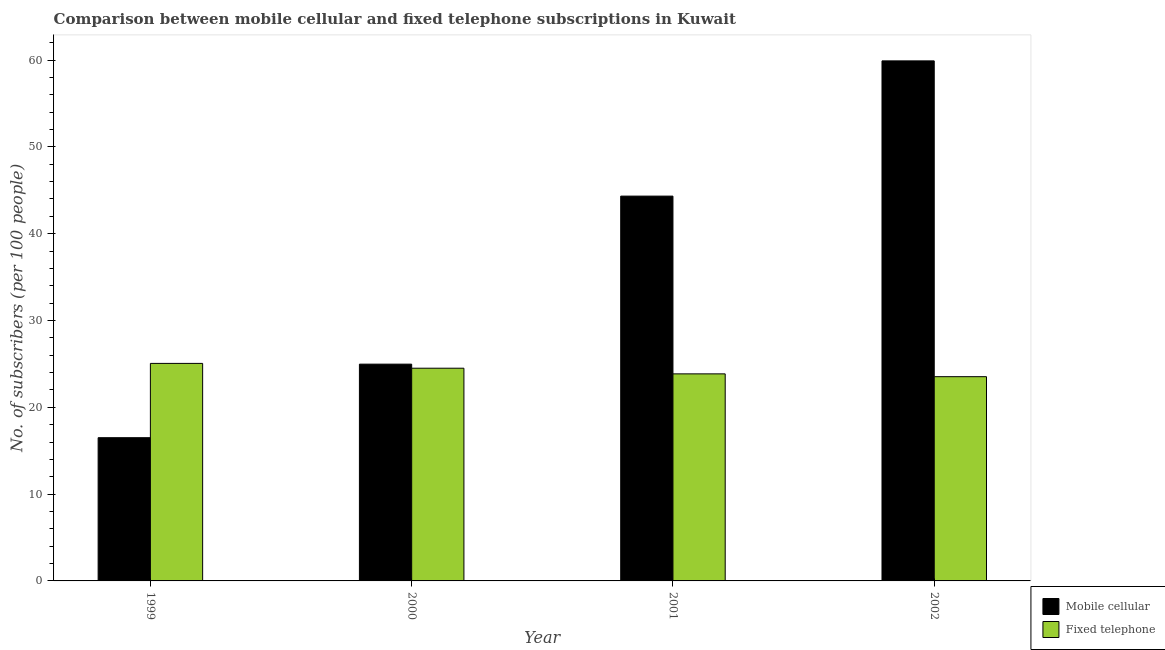How many different coloured bars are there?
Make the answer very short. 2. How many groups of bars are there?
Keep it short and to the point. 4. How many bars are there on the 3rd tick from the left?
Make the answer very short. 2. How many bars are there on the 4th tick from the right?
Ensure brevity in your answer.  2. In how many cases, is the number of bars for a given year not equal to the number of legend labels?
Your response must be concise. 0. What is the number of mobile cellular subscribers in 2000?
Ensure brevity in your answer.  24.97. Across all years, what is the maximum number of fixed telephone subscribers?
Your answer should be very brief. 25.06. Across all years, what is the minimum number of fixed telephone subscribers?
Give a very brief answer. 23.53. In which year was the number of mobile cellular subscribers minimum?
Give a very brief answer. 1999. What is the total number of fixed telephone subscribers in the graph?
Provide a succinct answer. 96.94. What is the difference between the number of fixed telephone subscribers in 2001 and that in 2002?
Give a very brief answer. 0.32. What is the difference between the number of mobile cellular subscribers in 2000 and the number of fixed telephone subscribers in 2002?
Provide a succinct answer. -34.93. What is the average number of fixed telephone subscribers per year?
Offer a terse response. 24.23. In the year 1999, what is the difference between the number of fixed telephone subscribers and number of mobile cellular subscribers?
Your answer should be compact. 0. What is the ratio of the number of mobile cellular subscribers in 1999 to that in 2001?
Your response must be concise. 0.37. Is the difference between the number of mobile cellular subscribers in 1999 and 2002 greater than the difference between the number of fixed telephone subscribers in 1999 and 2002?
Provide a short and direct response. No. What is the difference between the highest and the second highest number of fixed telephone subscribers?
Ensure brevity in your answer.  0.56. What is the difference between the highest and the lowest number of fixed telephone subscribers?
Ensure brevity in your answer.  1.53. Is the sum of the number of mobile cellular subscribers in 2000 and 2001 greater than the maximum number of fixed telephone subscribers across all years?
Ensure brevity in your answer.  Yes. What does the 1st bar from the left in 1999 represents?
Give a very brief answer. Mobile cellular. What does the 1st bar from the right in 2000 represents?
Make the answer very short. Fixed telephone. Are all the bars in the graph horizontal?
Keep it short and to the point. No. How many years are there in the graph?
Your response must be concise. 4. Are the values on the major ticks of Y-axis written in scientific E-notation?
Provide a short and direct response. No. Does the graph contain grids?
Offer a terse response. No. Where does the legend appear in the graph?
Provide a succinct answer. Bottom right. How many legend labels are there?
Ensure brevity in your answer.  2. What is the title of the graph?
Your answer should be compact. Comparison between mobile cellular and fixed telephone subscriptions in Kuwait. What is the label or title of the Y-axis?
Your response must be concise. No. of subscribers (per 100 people). What is the No. of subscribers (per 100 people) in Mobile cellular in 1999?
Give a very brief answer. 16.5. What is the No. of subscribers (per 100 people) in Fixed telephone in 1999?
Offer a terse response. 25.06. What is the No. of subscribers (per 100 people) in Mobile cellular in 2000?
Provide a short and direct response. 24.97. What is the No. of subscribers (per 100 people) of Fixed telephone in 2000?
Your answer should be compact. 24.5. What is the No. of subscribers (per 100 people) of Mobile cellular in 2001?
Keep it short and to the point. 44.33. What is the No. of subscribers (per 100 people) of Fixed telephone in 2001?
Offer a very short reply. 23.85. What is the No. of subscribers (per 100 people) of Mobile cellular in 2002?
Ensure brevity in your answer.  59.91. What is the No. of subscribers (per 100 people) in Fixed telephone in 2002?
Your answer should be compact. 23.53. Across all years, what is the maximum No. of subscribers (per 100 people) in Mobile cellular?
Your answer should be compact. 59.91. Across all years, what is the maximum No. of subscribers (per 100 people) of Fixed telephone?
Provide a succinct answer. 25.06. Across all years, what is the minimum No. of subscribers (per 100 people) of Mobile cellular?
Your response must be concise. 16.5. Across all years, what is the minimum No. of subscribers (per 100 people) of Fixed telephone?
Provide a short and direct response. 23.53. What is the total No. of subscribers (per 100 people) of Mobile cellular in the graph?
Your response must be concise. 145.7. What is the total No. of subscribers (per 100 people) of Fixed telephone in the graph?
Provide a short and direct response. 96.94. What is the difference between the No. of subscribers (per 100 people) in Mobile cellular in 1999 and that in 2000?
Keep it short and to the point. -8.47. What is the difference between the No. of subscribers (per 100 people) of Fixed telephone in 1999 and that in 2000?
Provide a short and direct response. 0.56. What is the difference between the No. of subscribers (per 100 people) of Mobile cellular in 1999 and that in 2001?
Offer a terse response. -27.83. What is the difference between the No. of subscribers (per 100 people) in Fixed telephone in 1999 and that in 2001?
Keep it short and to the point. 1.21. What is the difference between the No. of subscribers (per 100 people) in Mobile cellular in 1999 and that in 2002?
Give a very brief answer. -43.41. What is the difference between the No. of subscribers (per 100 people) in Fixed telephone in 1999 and that in 2002?
Offer a very short reply. 1.53. What is the difference between the No. of subscribers (per 100 people) of Mobile cellular in 2000 and that in 2001?
Offer a terse response. -19.36. What is the difference between the No. of subscribers (per 100 people) in Fixed telephone in 2000 and that in 2001?
Your answer should be very brief. 0.65. What is the difference between the No. of subscribers (per 100 people) in Mobile cellular in 2000 and that in 2002?
Give a very brief answer. -34.93. What is the difference between the No. of subscribers (per 100 people) of Fixed telephone in 2000 and that in 2002?
Your answer should be compact. 0.97. What is the difference between the No. of subscribers (per 100 people) in Mobile cellular in 2001 and that in 2002?
Ensure brevity in your answer.  -15.58. What is the difference between the No. of subscribers (per 100 people) in Fixed telephone in 2001 and that in 2002?
Your response must be concise. 0.32. What is the difference between the No. of subscribers (per 100 people) of Mobile cellular in 1999 and the No. of subscribers (per 100 people) of Fixed telephone in 2000?
Make the answer very short. -8. What is the difference between the No. of subscribers (per 100 people) in Mobile cellular in 1999 and the No. of subscribers (per 100 people) in Fixed telephone in 2001?
Offer a terse response. -7.35. What is the difference between the No. of subscribers (per 100 people) in Mobile cellular in 1999 and the No. of subscribers (per 100 people) in Fixed telephone in 2002?
Your response must be concise. -7.03. What is the difference between the No. of subscribers (per 100 people) in Mobile cellular in 2000 and the No. of subscribers (per 100 people) in Fixed telephone in 2001?
Your response must be concise. 1.12. What is the difference between the No. of subscribers (per 100 people) in Mobile cellular in 2000 and the No. of subscribers (per 100 people) in Fixed telephone in 2002?
Offer a very short reply. 1.44. What is the difference between the No. of subscribers (per 100 people) of Mobile cellular in 2001 and the No. of subscribers (per 100 people) of Fixed telephone in 2002?
Your answer should be very brief. 20.8. What is the average No. of subscribers (per 100 people) in Mobile cellular per year?
Make the answer very short. 36.42. What is the average No. of subscribers (per 100 people) of Fixed telephone per year?
Offer a terse response. 24.23. In the year 1999, what is the difference between the No. of subscribers (per 100 people) of Mobile cellular and No. of subscribers (per 100 people) of Fixed telephone?
Ensure brevity in your answer.  -8.56. In the year 2000, what is the difference between the No. of subscribers (per 100 people) of Mobile cellular and No. of subscribers (per 100 people) of Fixed telephone?
Your response must be concise. 0.47. In the year 2001, what is the difference between the No. of subscribers (per 100 people) in Mobile cellular and No. of subscribers (per 100 people) in Fixed telephone?
Make the answer very short. 20.47. In the year 2002, what is the difference between the No. of subscribers (per 100 people) in Mobile cellular and No. of subscribers (per 100 people) in Fixed telephone?
Your answer should be very brief. 36.38. What is the ratio of the No. of subscribers (per 100 people) in Mobile cellular in 1999 to that in 2000?
Provide a short and direct response. 0.66. What is the ratio of the No. of subscribers (per 100 people) of Fixed telephone in 1999 to that in 2000?
Offer a very short reply. 1.02. What is the ratio of the No. of subscribers (per 100 people) of Mobile cellular in 1999 to that in 2001?
Your response must be concise. 0.37. What is the ratio of the No. of subscribers (per 100 people) in Fixed telephone in 1999 to that in 2001?
Provide a short and direct response. 1.05. What is the ratio of the No. of subscribers (per 100 people) of Mobile cellular in 1999 to that in 2002?
Your answer should be compact. 0.28. What is the ratio of the No. of subscribers (per 100 people) in Fixed telephone in 1999 to that in 2002?
Provide a short and direct response. 1.06. What is the ratio of the No. of subscribers (per 100 people) in Mobile cellular in 2000 to that in 2001?
Provide a succinct answer. 0.56. What is the ratio of the No. of subscribers (per 100 people) of Fixed telephone in 2000 to that in 2001?
Offer a terse response. 1.03. What is the ratio of the No. of subscribers (per 100 people) in Mobile cellular in 2000 to that in 2002?
Your response must be concise. 0.42. What is the ratio of the No. of subscribers (per 100 people) in Fixed telephone in 2000 to that in 2002?
Your answer should be very brief. 1.04. What is the ratio of the No. of subscribers (per 100 people) of Mobile cellular in 2001 to that in 2002?
Offer a very short reply. 0.74. What is the ratio of the No. of subscribers (per 100 people) of Fixed telephone in 2001 to that in 2002?
Your answer should be very brief. 1.01. What is the difference between the highest and the second highest No. of subscribers (per 100 people) in Mobile cellular?
Your answer should be compact. 15.58. What is the difference between the highest and the second highest No. of subscribers (per 100 people) of Fixed telephone?
Your answer should be very brief. 0.56. What is the difference between the highest and the lowest No. of subscribers (per 100 people) in Mobile cellular?
Offer a terse response. 43.41. What is the difference between the highest and the lowest No. of subscribers (per 100 people) in Fixed telephone?
Your answer should be compact. 1.53. 